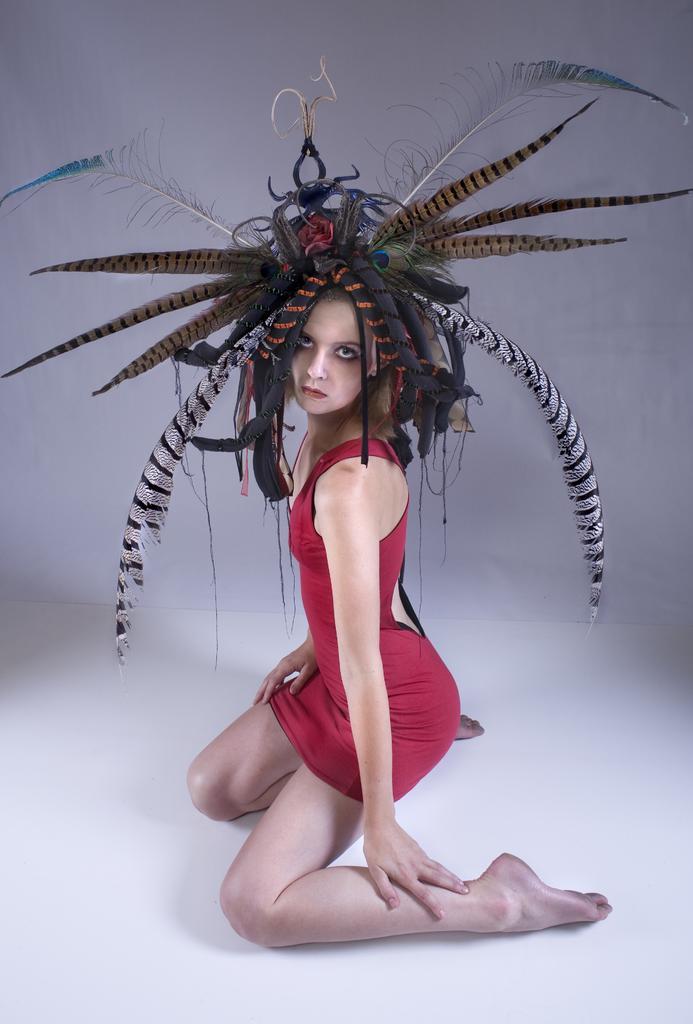Can you describe this image briefly? In this image there are some decorations on the head of the person and the wall. 